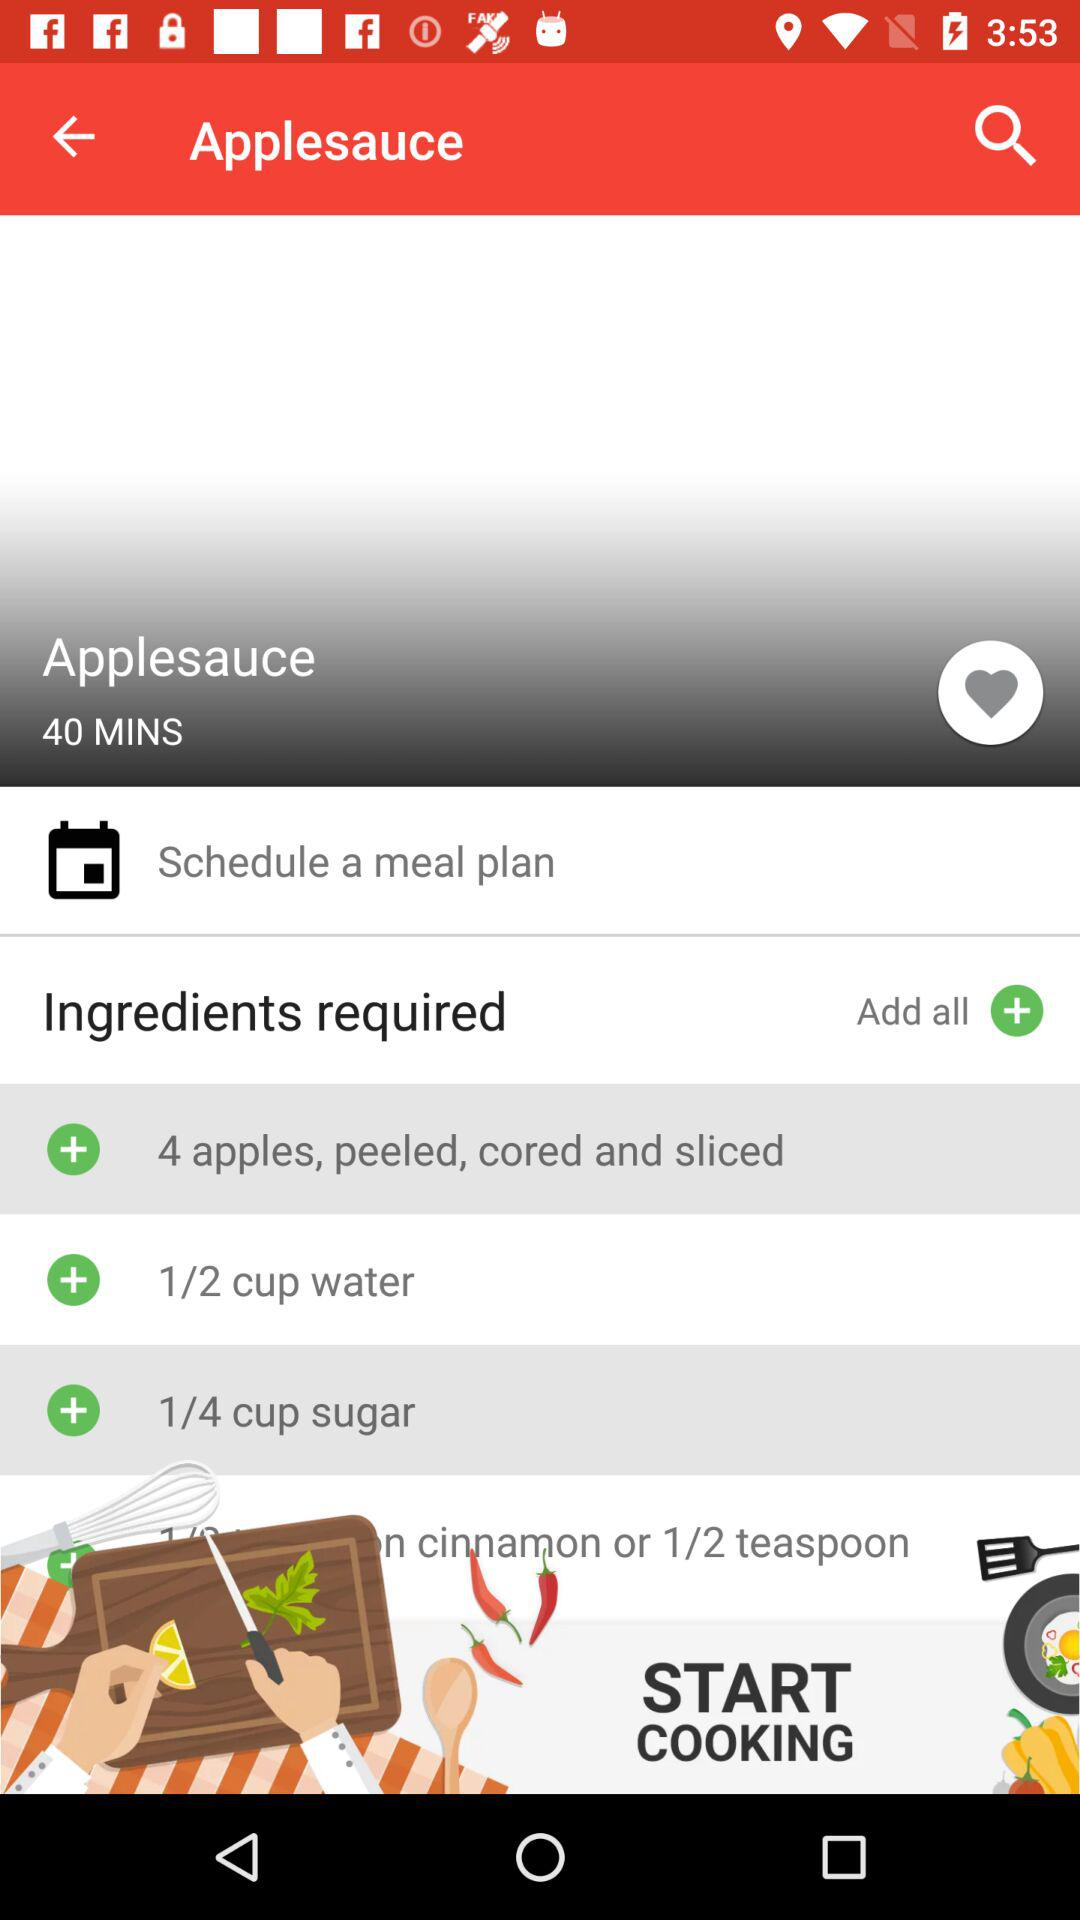How much time will it take to make the dish? It will take 40 minutes to make the dish. 